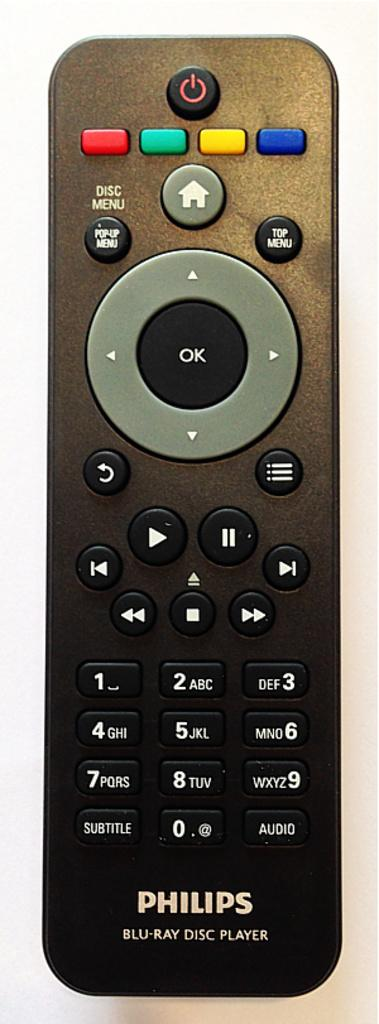<image>
Share a concise interpretation of the image provided. A Philips brand remote has colorful buttons at the top. 